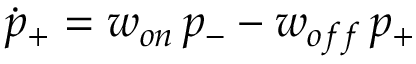Convert formula to latex. <formula><loc_0><loc_0><loc_500><loc_500>\dot { p } _ { + } = w _ { o n } \, p _ { - } - w _ { o f f } \, p _ { + }</formula> 